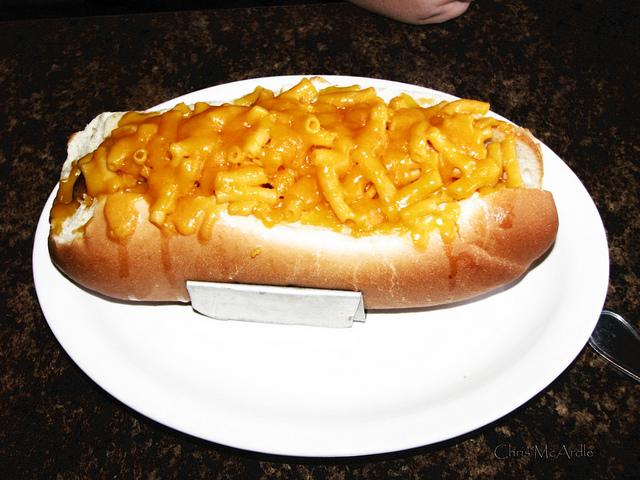Would you consider this a healthy meal?
Answer briefly. No. What shape is the plate?
Concise answer only. Circle. Do you need a fork to eat this?
Write a very short answer. No. Where is the sauerkraut?
Concise answer only. Under macaroni and cheese. 